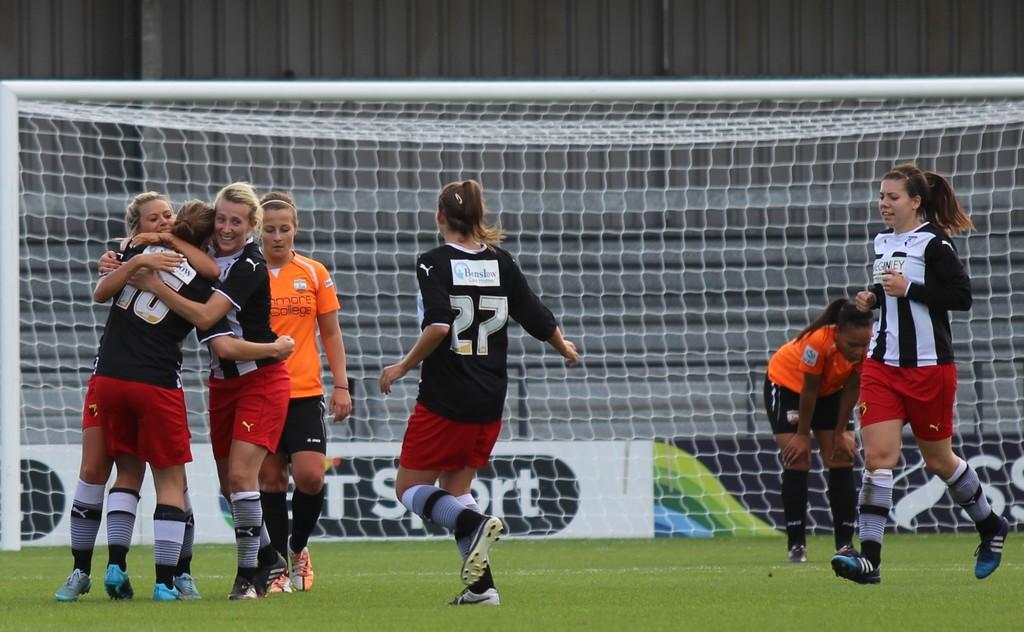What is the number of the black shirt running up to the hugging girls?
Give a very brief answer. 27. What sport are they playing?
Provide a short and direct response. Answering does not require reading text in the image. 